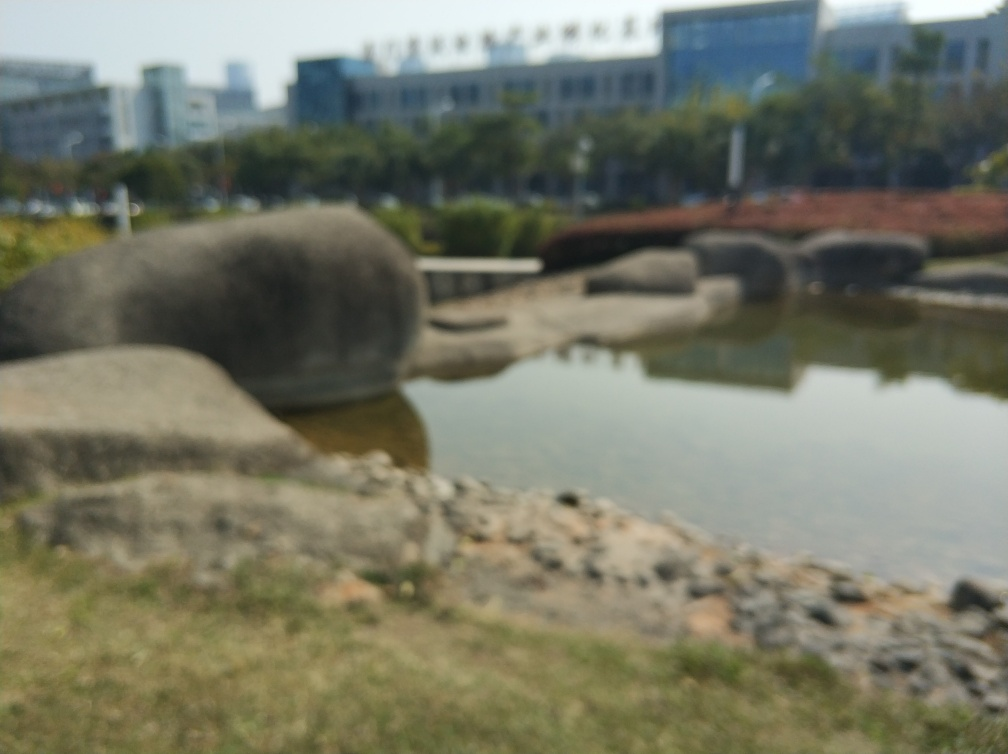Is the quality of this image poor? Yes, the image is blurry, which affects the clarity of the subjects in the photo. It's difficult to discern the details of the environment due to the lack of focus. Improving sharpness could significantly enhance the image quality. 